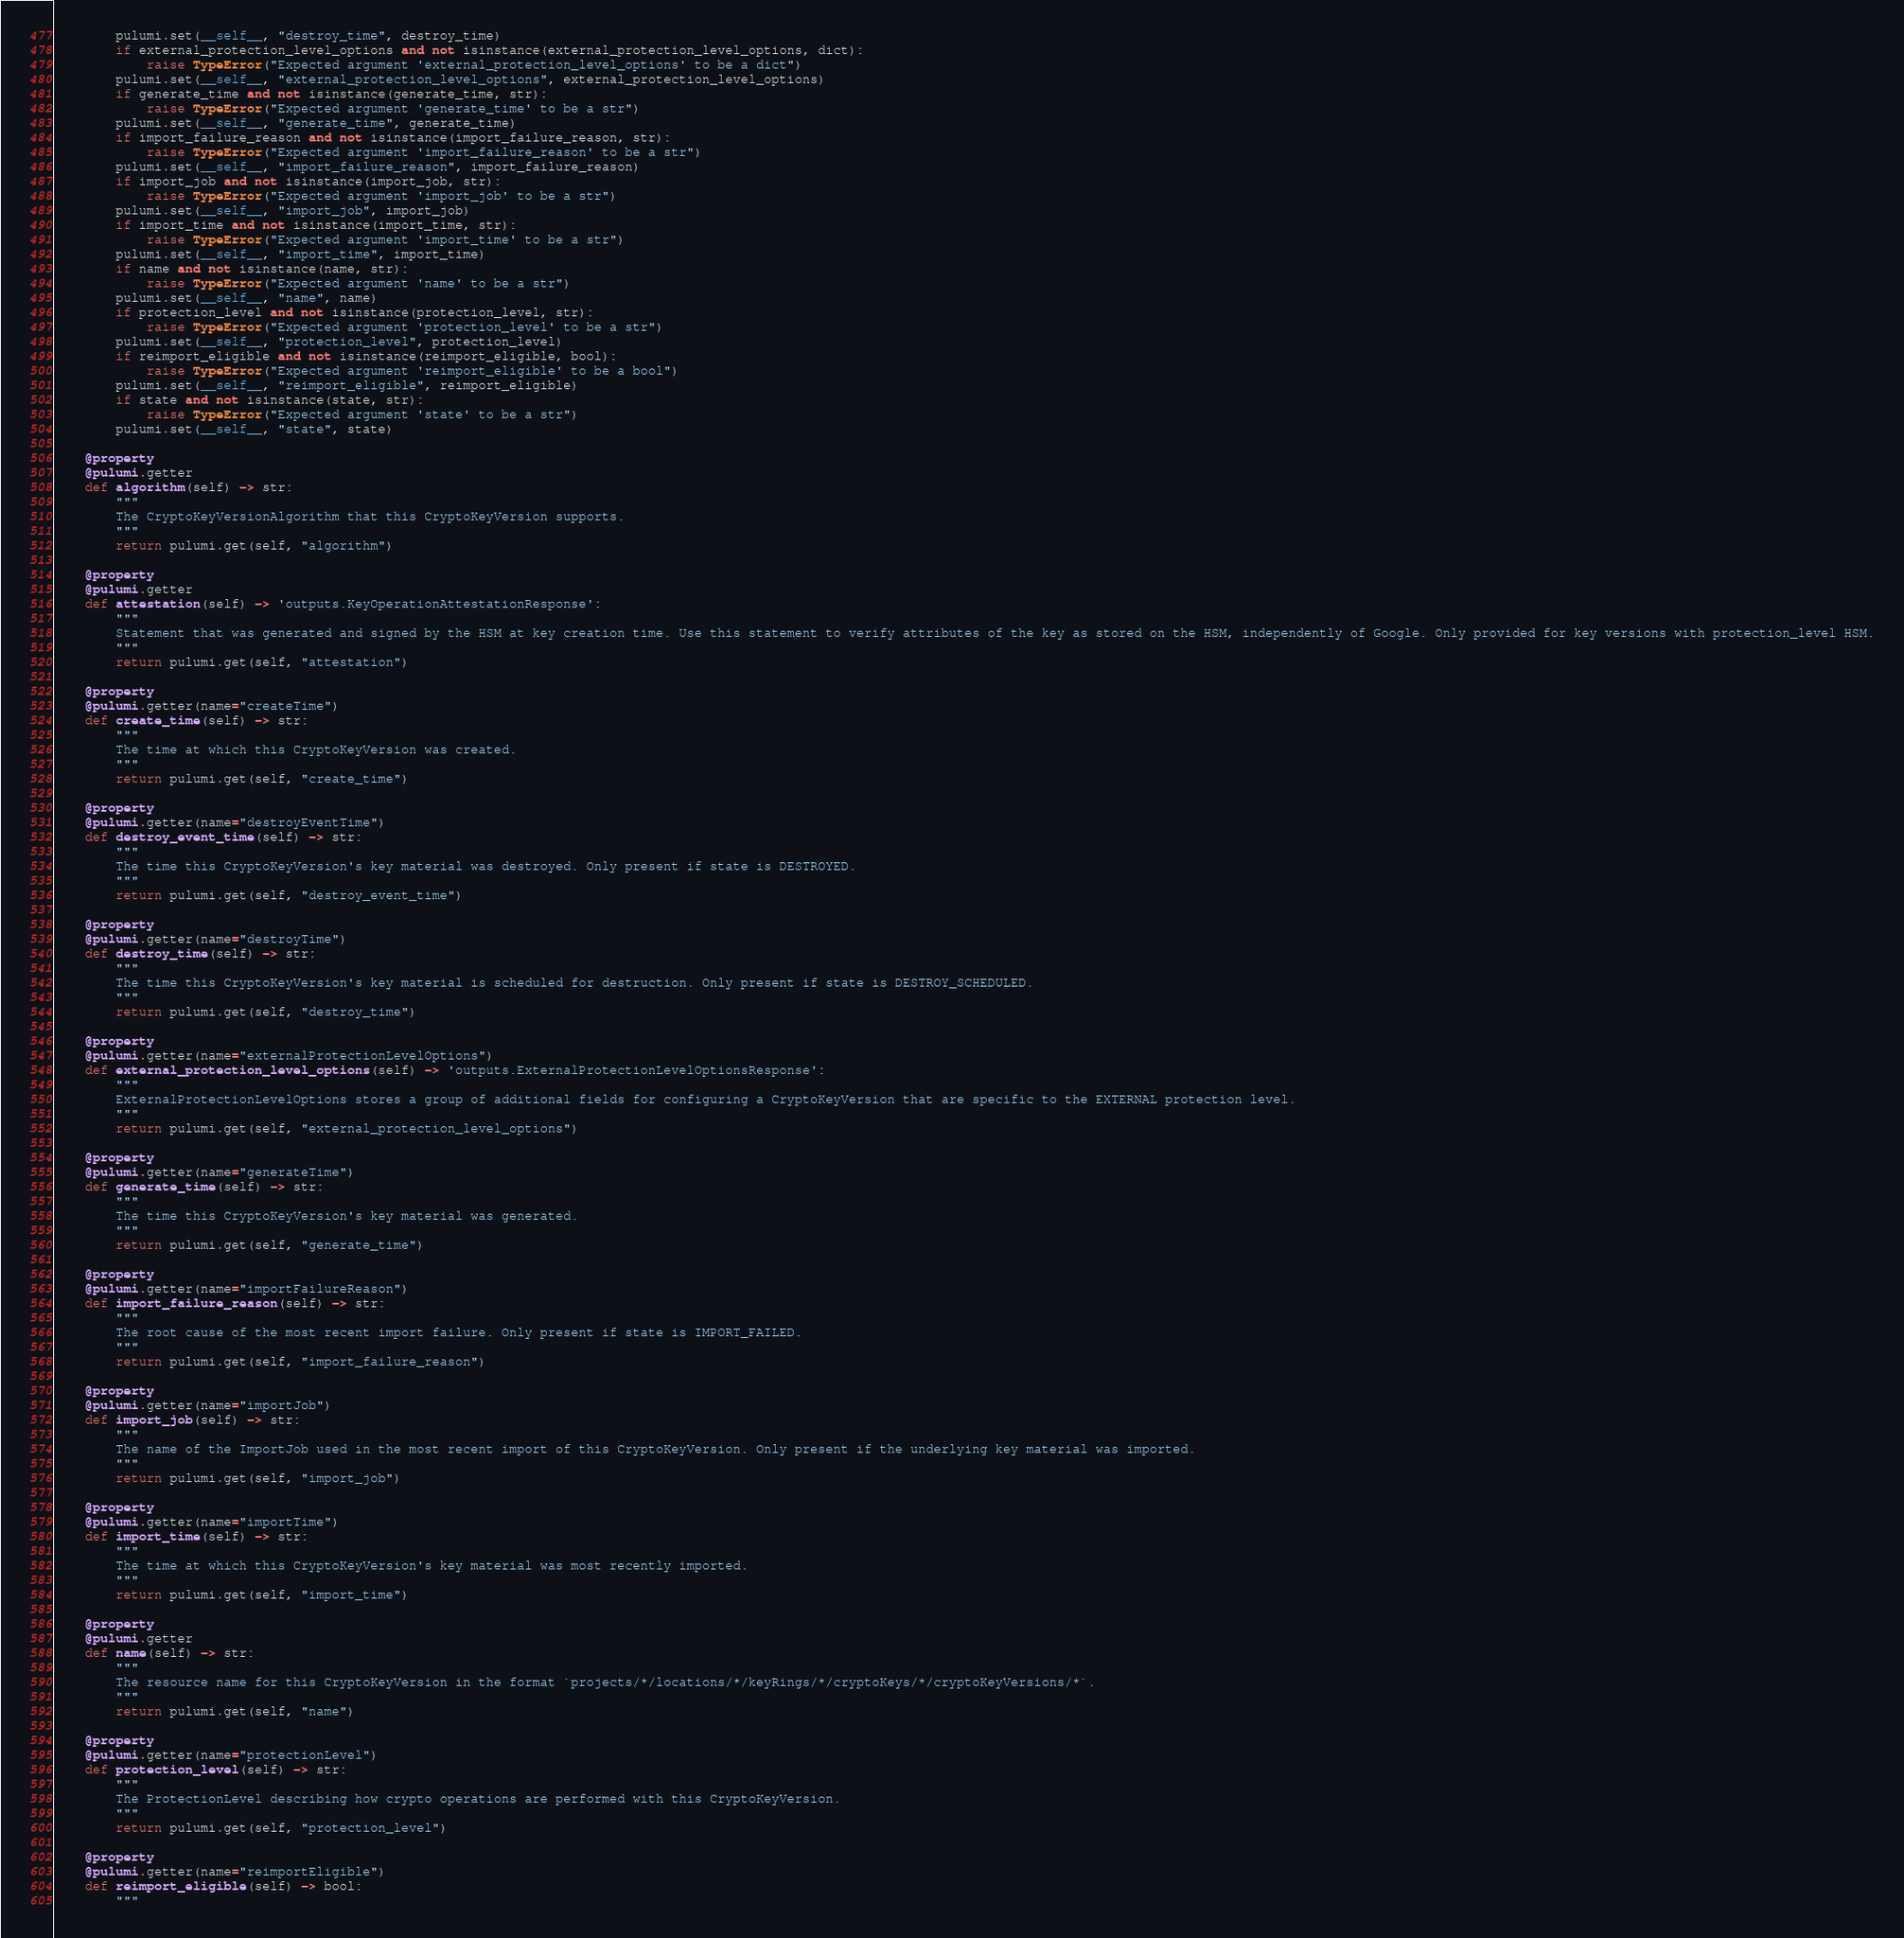<code> <loc_0><loc_0><loc_500><loc_500><_Python_>        pulumi.set(__self__, "destroy_time", destroy_time)
        if external_protection_level_options and not isinstance(external_protection_level_options, dict):
            raise TypeError("Expected argument 'external_protection_level_options' to be a dict")
        pulumi.set(__self__, "external_protection_level_options", external_protection_level_options)
        if generate_time and not isinstance(generate_time, str):
            raise TypeError("Expected argument 'generate_time' to be a str")
        pulumi.set(__self__, "generate_time", generate_time)
        if import_failure_reason and not isinstance(import_failure_reason, str):
            raise TypeError("Expected argument 'import_failure_reason' to be a str")
        pulumi.set(__self__, "import_failure_reason", import_failure_reason)
        if import_job and not isinstance(import_job, str):
            raise TypeError("Expected argument 'import_job' to be a str")
        pulumi.set(__self__, "import_job", import_job)
        if import_time and not isinstance(import_time, str):
            raise TypeError("Expected argument 'import_time' to be a str")
        pulumi.set(__self__, "import_time", import_time)
        if name and not isinstance(name, str):
            raise TypeError("Expected argument 'name' to be a str")
        pulumi.set(__self__, "name", name)
        if protection_level and not isinstance(protection_level, str):
            raise TypeError("Expected argument 'protection_level' to be a str")
        pulumi.set(__self__, "protection_level", protection_level)
        if reimport_eligible and not isinstance(reimport_eligible, bool):
            raise TypeError("Expected argument 'reimport_eligible' to be a bool")
        pulumi.set(__self__, "reimport_eligible", reimport_eligible)
        if state and not isinstance(state, str):
            raise TypeError("Expected argument 'state' to be a str")
        pulumi.set(__self__, "state", state)

    @property
    @pulumi.getter
    def algorithm(self) -> str:
        """
        The CryptoKeyVersionAlgorithm that this CryptoKeyVersion supports.
        """
        return pulumi.get(self, "algorithm")

    @property
    @pulumi.getter
    def attestation(self) -> 'outputs.KeyOperationAttestationResponse':
        """
        Statement that was generated and signed by the HSM at key creation time. Use this statement to verify attributes of the key as stored on the HSM, independently of Google. Only provided for key versions with protection_level HSM.
        """
        return pulumi.get(self, "attestation")

    @property
    @pulumi.getter(name="createTime")
    def create_time(self) -> str:
        """
        The time at which this CryptoKeyVersion was created.
        """
        return pulumi.get(self, "create_time")

    @property
    @pulumi.getter(name="destroyEventTime")
    def destroy_event_time(self) -> str:
        """
        The time this CryptoKeyVersion's key material was destroyed. Only present if state is DESTROYED.
        """
        return pulumi.get(self, "destroy_event_time")

    @property
    @pulumi.getter(name="destroyTime")
    def destroy_time(self) -> str:
        """
        The time this CryptoKeyVersion's key material is scheduled for destruction. Only present if state is DESTROY_SCHEDULED.
        """
        return pulumi.get(self, "destroy_time")

    @property
    @pulumi.getter(name="externalProtectionLevelOptions")
    def external_protection_level_options(self) -> 'outputs.ExternalProtectionLevelOptionsResponse':
        """
        ExternalProtectionLevelOptions stores a group of additional fields for configuring a CryptoKeyVersion that are specific to the EXTERNAL protection level.
        """
        return pulumi.get(self, "external_protection_level_options")

    @property
    @pulumi.getter(name="generateTime")
    def generate_time(self) -> str:
        """
        The time this CryptoKeyVersion's key material was generated.
        """
        return pulumi.get(self, "generate_time")

    @property
    @pulumi.getter(name="importFailureReason")
    def import_failure_reason(self) -> str:
        """
        The root cause of the most recent import failure. Only present if state is IMPORT_FAILED.
        """
        return pulumi.get(self, "import_failure_reason")

    @property
    @pulumi.getter(name="importJob")
    def import_job(self) -> str:
        """
        The name of the ImportJob used in the most recent import of this CryptoKeyVersion. Only present if the underlying key material was imported.
        """
        return pulumi.get(self, "import_job")

    @property
    @pulumi.getter(name="importTime")
    def import_time(self) -> str:
        """
        The time at which this CryptoKeyVersion's key material was most recently imported.
        """
        return pulumi.get(self, "import_time")

    @property
    @pulumi.getter
    def name(self) -> str:
        """
        The resource name for this CryptoKeyVersion in the format `projects/*/locations/*/keyRings/*/cryptoKeys/*/cryptoKeyVersions/*`.
        """
        return pulumi.get(self, "name")

    @property
    @pulumi.getter(name="protectionLevel")
    def protection_level(self) -> str:
        """
        The ProtectionLevel describing how crypto operations are performed with this CryptoKeyVersion.
        """
        return pulumi.get(self, "protection_level")

    @property
    @pulumi.getter(name="reimportEligible")
    def reimport_eligible(self) -> bool:
        """</code> 